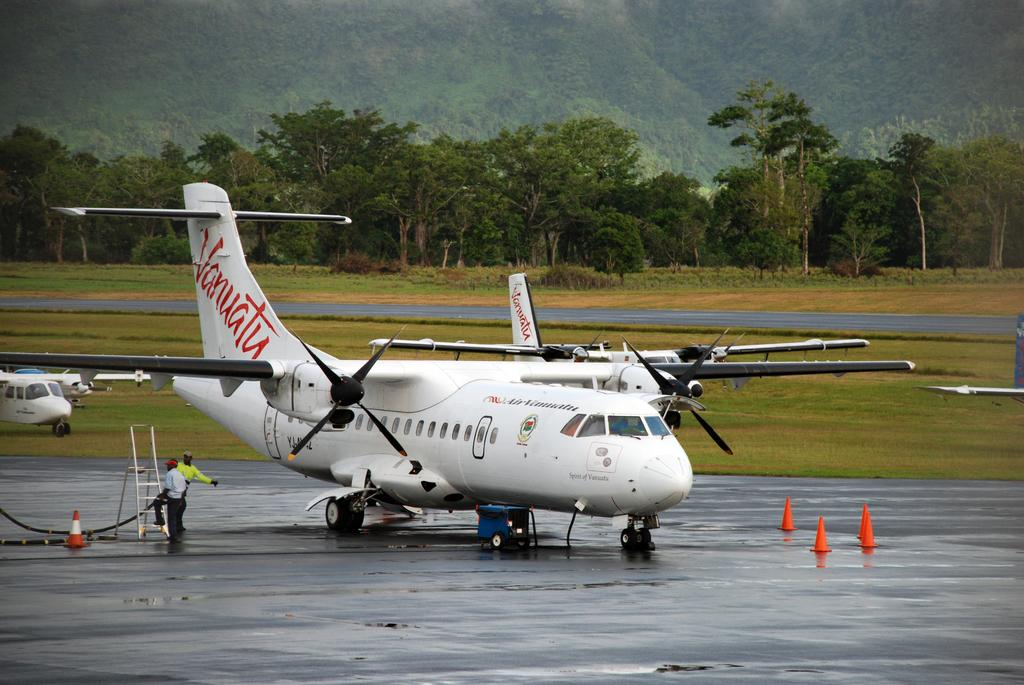What is the main subject of the image? The main subject of the image is planes. Can you describe the people in the image? There are two people standing on the earth's surface in the image. What objects are present in the image that might be used for climbing or reaching higher places? There is a ladder in the image. What items are present in the image that are used for directing traffic or marking hazards? There are traffic cones in the image. What type of vegetation can be seen in the image? There is grass and trees in the image. What part of the natural environment is visible in the image? The sky is visible in the image. Reasoning: Let's think step by following the given guidelines to produce the conversation. We start by identifying the main subject of the image, which is the planes. Then, we describe the people and other objects present in the image, ensuring that each question can be answered definitively with the information given. We avoid yes/no questions and ensure that the language is simple and clear. Absurd Question/Answer: What type of lettuce is being kicked by one of the people in the image? There is no lettuce or kicking activity present in the image. Can you describe the chair that one of the people is sitting on in the image? There is no chair present in the image; the two people are standing on the earth's surface. What type of lettuce is being kicked by one of the people in the image? There is no lettuce or kicking activity present in the image. Can you describe the chair that one of the people is sitting on in the image? There is no chair present in the image; the two people are standing on the earth's surface. 